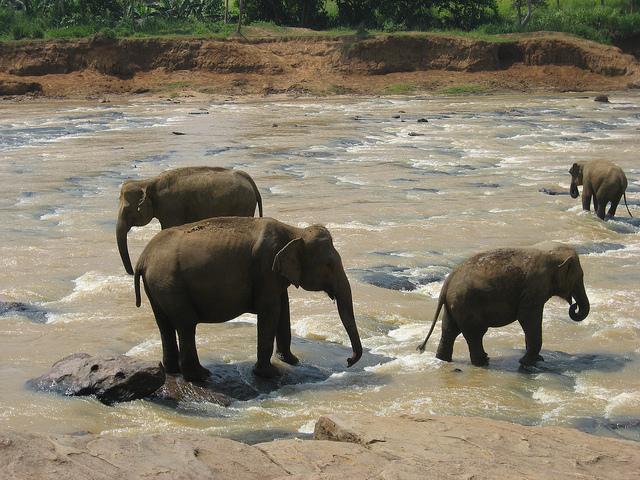How many elephants are in the picture?
Give a very brief answer. 4. 